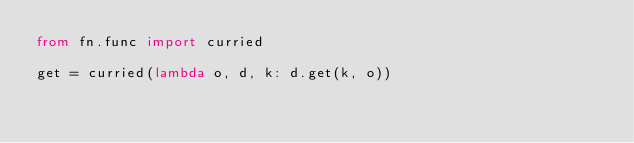Convert code to text. <code><loc_0><loc_0><loc_500><loc_500><_Python_>from fn.func import curried

get = curried(lambda o, d, k: d.get(k, o))</code> 